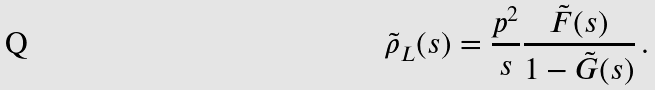Convert formula to latex. <formula><loc_0><loc_0><loc_500><loc_500>\tilde { \rho } _ { L } ( s ) = \frac { p ^ { 2 } } { s } \frac { \tilde { F } ( s ) } { 1 - \tilde { G } ( s ) } \, .</formula> 